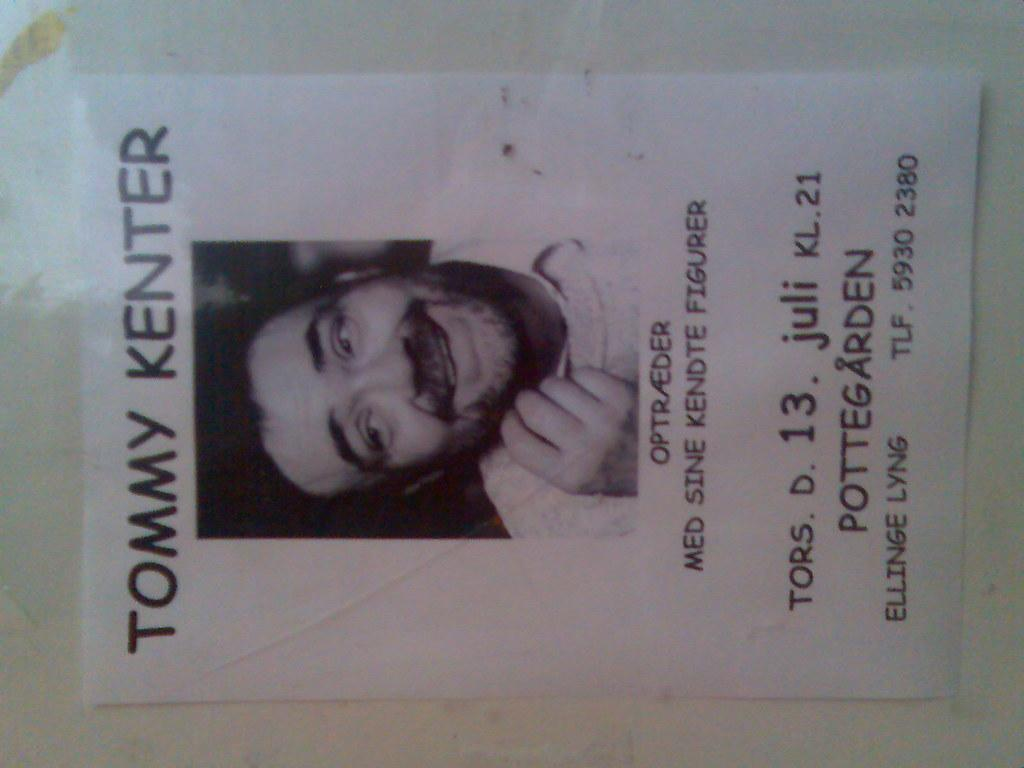What is depicted on the poster in the foreground? There is a poster of a person on the wall in the foreground. Can you describe the lighting conditions in the image? The image was likely taken during the day, as the lighting appears to be natural and bright. What type of bomb is being used by the laborer in the image? There is no bomb or laborer present in the image; it only features a poster of a person on the wall. How many chairs are visible in the image? There are no chairs visible in the image. 